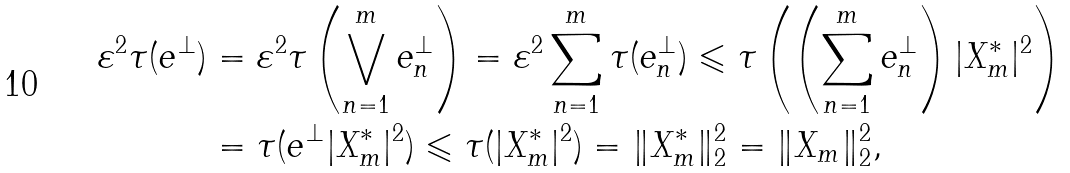Convert formula to latex. <formula><loc_0><loc_0><loc_500><loc_500>\varepsilon ^ { 2 } \tau ( e ^ { \bot } ) & = \varepsilon ^ { 2 } \tau \left ( \bigvee _ { n = 1 } ^ { m } e _ { n } ^ { \bot } \right ) = \varepsilon ^ { 2 } \sum _ { n = 1 } ^ { m } \tau ( e _ { n } ^ { \bot } ) \leqslant \tau \left ( \left ( \sum _ { n = 1 } ^ { m } e _ { n } ^ { \bot } \right ) | X _ { m } ^ { * } | ^ { 2 } \right ) \\ & = \tau ( e ^ { \bot } | X _ { m } ^ { * } | ^ { 2 } ) \leqslant \tau ( | X _ { m } ^ { * } | ^ { 2 } ) = \| X _ { m } ^ { * } \| _ { 2 } ^ { 2 } = \| X _ { m } \| _ { 2 } ^ { 2 } ,</formula> 